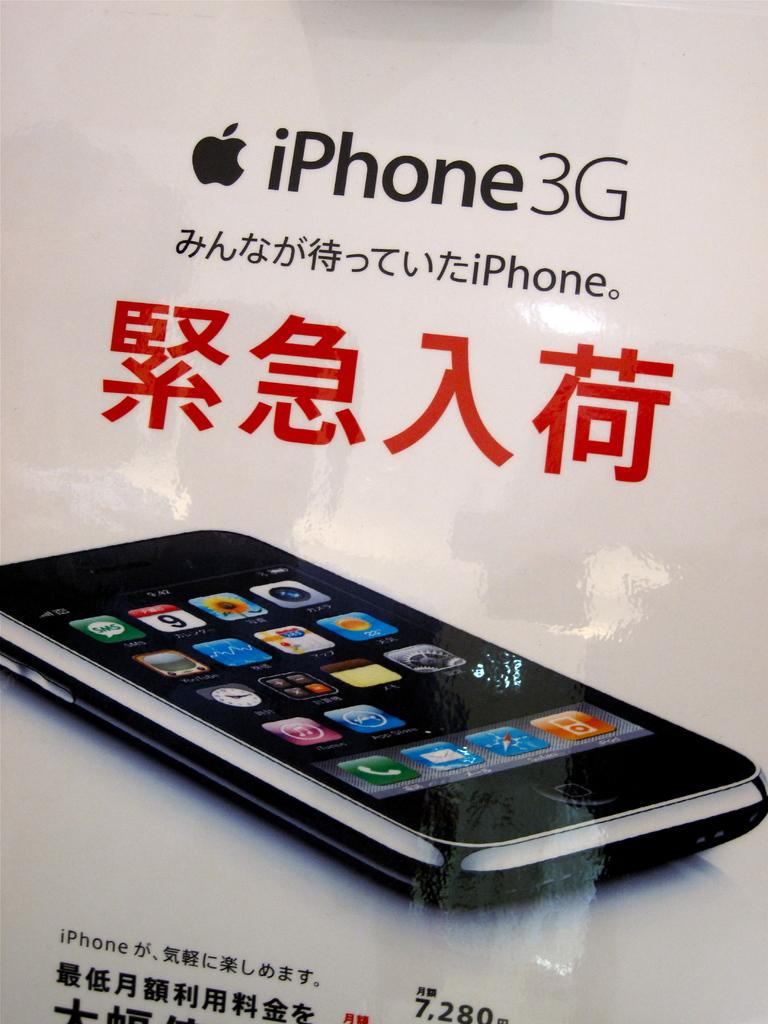What kind of phone is this?
Your answer should be compact. Iphone 3g. Is this chinese?
Your answer should be compact. Yes. 